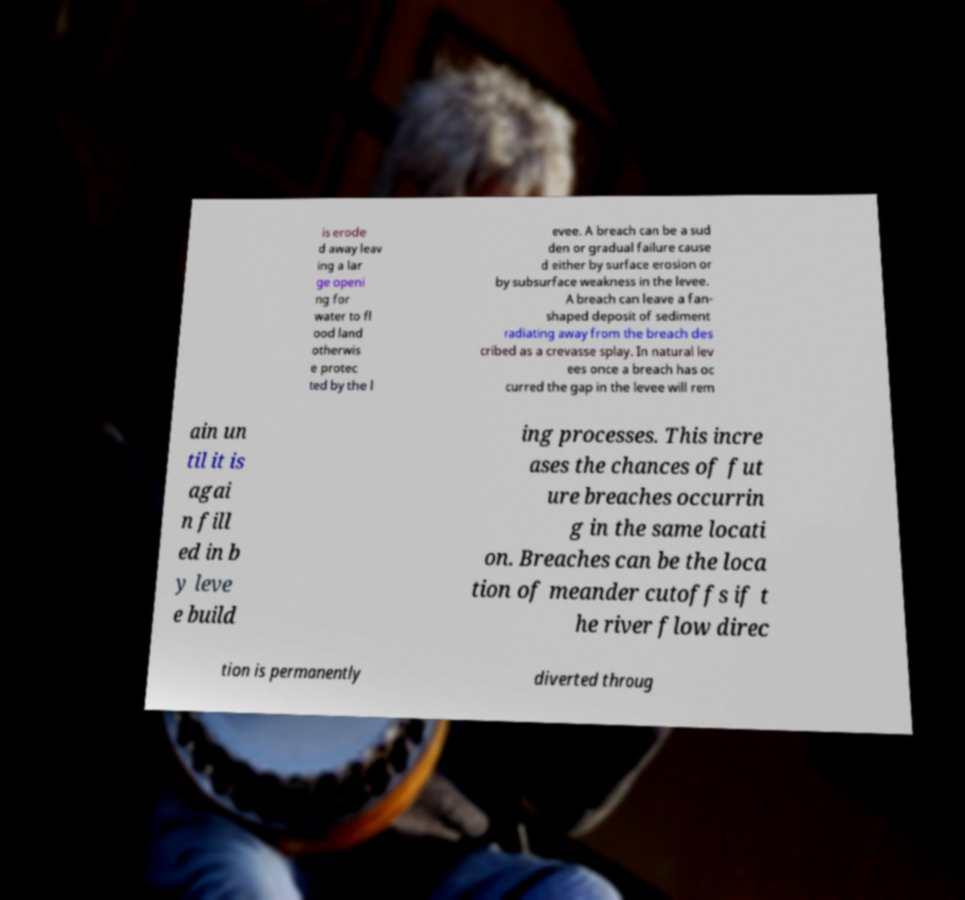There's text embedded in this image that I need extracted. Can you transcribe it verbatim? is erode d away leav ing a lar ge openi ng for water to fl ood land otherwis e protec ted by the l evee. A breach can be a sud den or gradual failure cause d either by surface erosion or by subsurface weakness in the levee. A breach can leave a fan- shaped deposit of sediment radiating away from the breach des cribed as a crevasse splay. In natural lev ees once a breach has oc curred the gap in the levee will rem ain un til it is agai n fill ed in b y leve e build ing processes. This incre ases the chances of fut ure breaches occurrin g in the same locati on. Breaches can be the loca tion of meander cutoffs if t he river flow direc tion is permanently diverted throug 